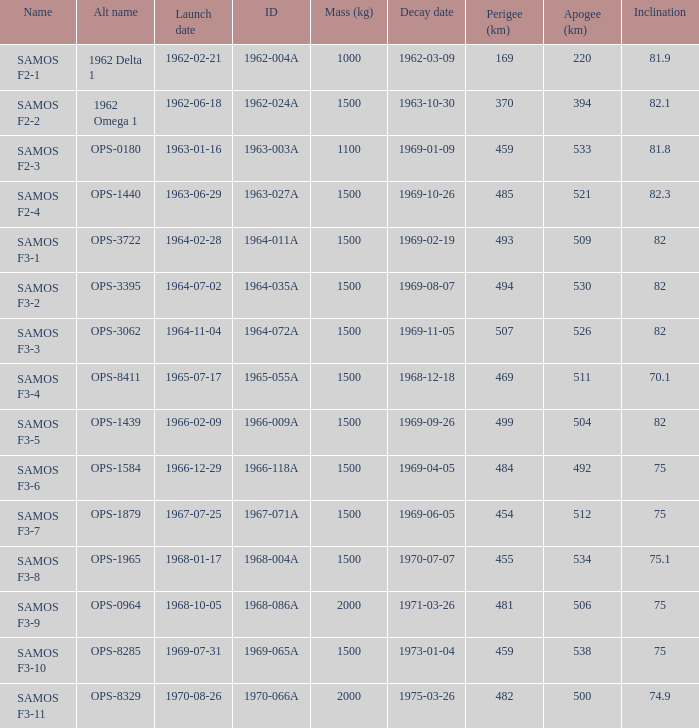What is the count of alternative names for 1964-011a? 1.0. 